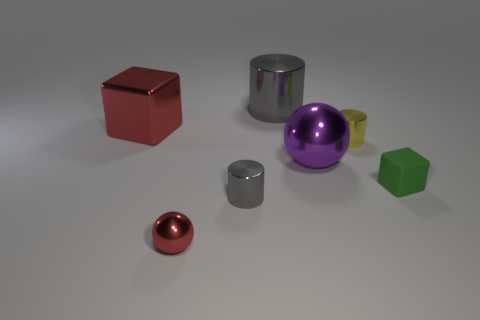How many yellow metal cylinders are there?
Keep it short and to the point. 1. What is the color of the cylinder that is behind the big metallic thing that is on the left side of the tiny red ball?
Ensure brevity in your answer.  Gray. There is a metallic sphere that is the same size as the red metal block; what color is it?
Make the answer very short. Purple. Are there any rubber cubes that have the same color as the tiny metallic ball?
Your answer should be compact. No. Are there any rubber blocks?
Provide a succinct answer. Yes. What is the shape of the gray metallic thing in front of the yellow object?
Ensure brevity in your answer.  Cylinder. How many small metallic objects are behind the small rubber cube and to the left of the large metallic cylinder?
Ensure brevity in your answer.  0. What number of other things are there of the same size as the matte thing?
Your answer should be compact. 3. Do the big metallic object to the left of the tiny red metal thing and the gray object in front of the purple metallic ball have the same shape?
Your response must be concise. No. How many objects are either large gray shiny cylinders or metal cylinders that are in front of the large metal cube?
Provide a succinct answer. 3. 